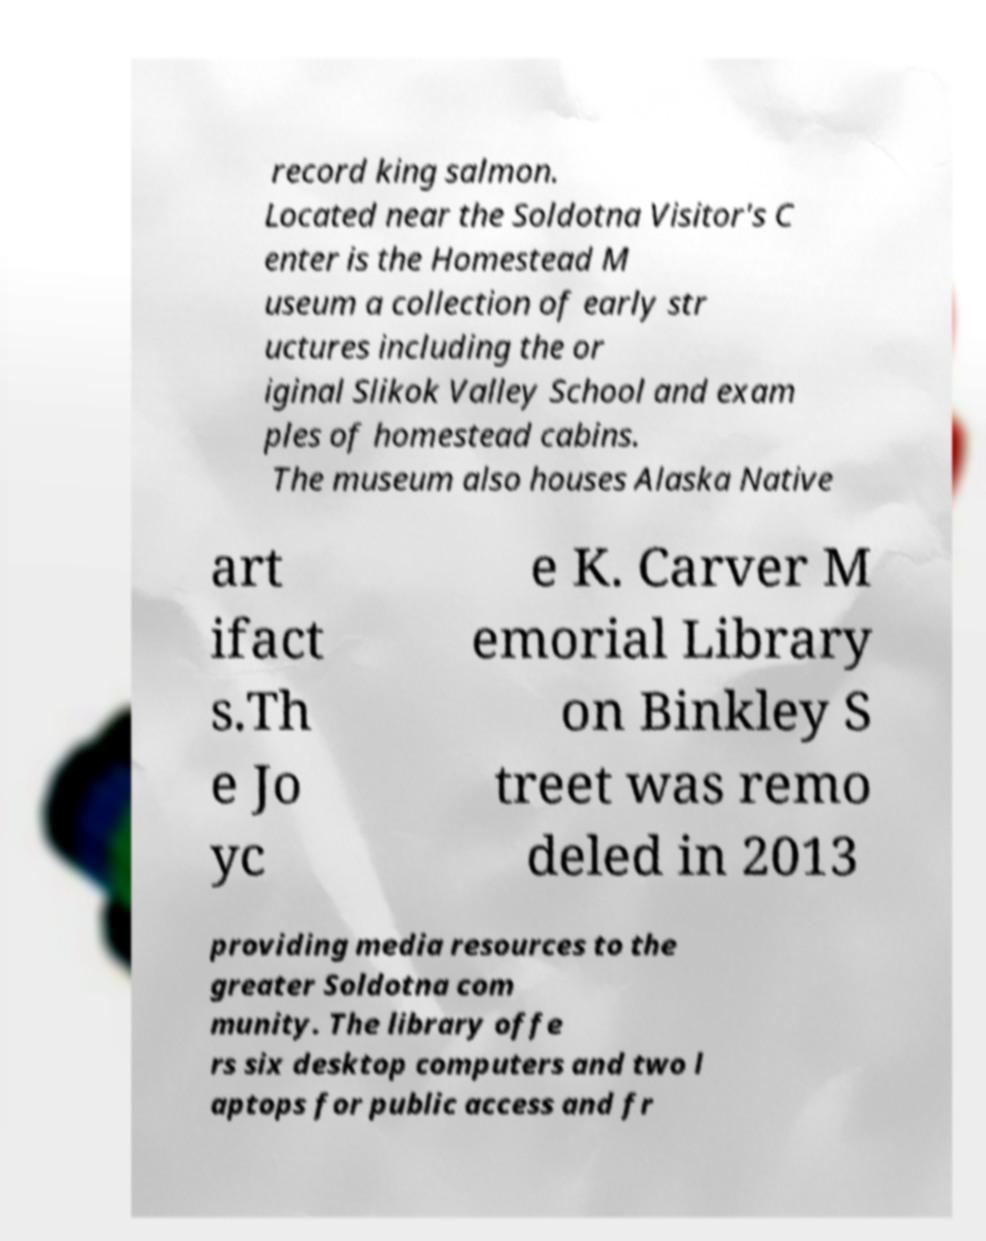For documentation purposes, I need the text within this image transcribed. Could you provide that? record king salmon. Located near the Soldotna Visitor's C enter is the Homestead M useum a collection of early str uctures including the or iginal Slikok Valley School and exam ples of homestead cabins. The museum also houses Alaska Native art ifact s.Th e Jo yc e K. Carver M emorial Library on Binkley S treet was remo deled in 2013 providing media resources to the greater Soldotna com munity. The library offe rs six desktop computers and two l aptops for public access and fr 